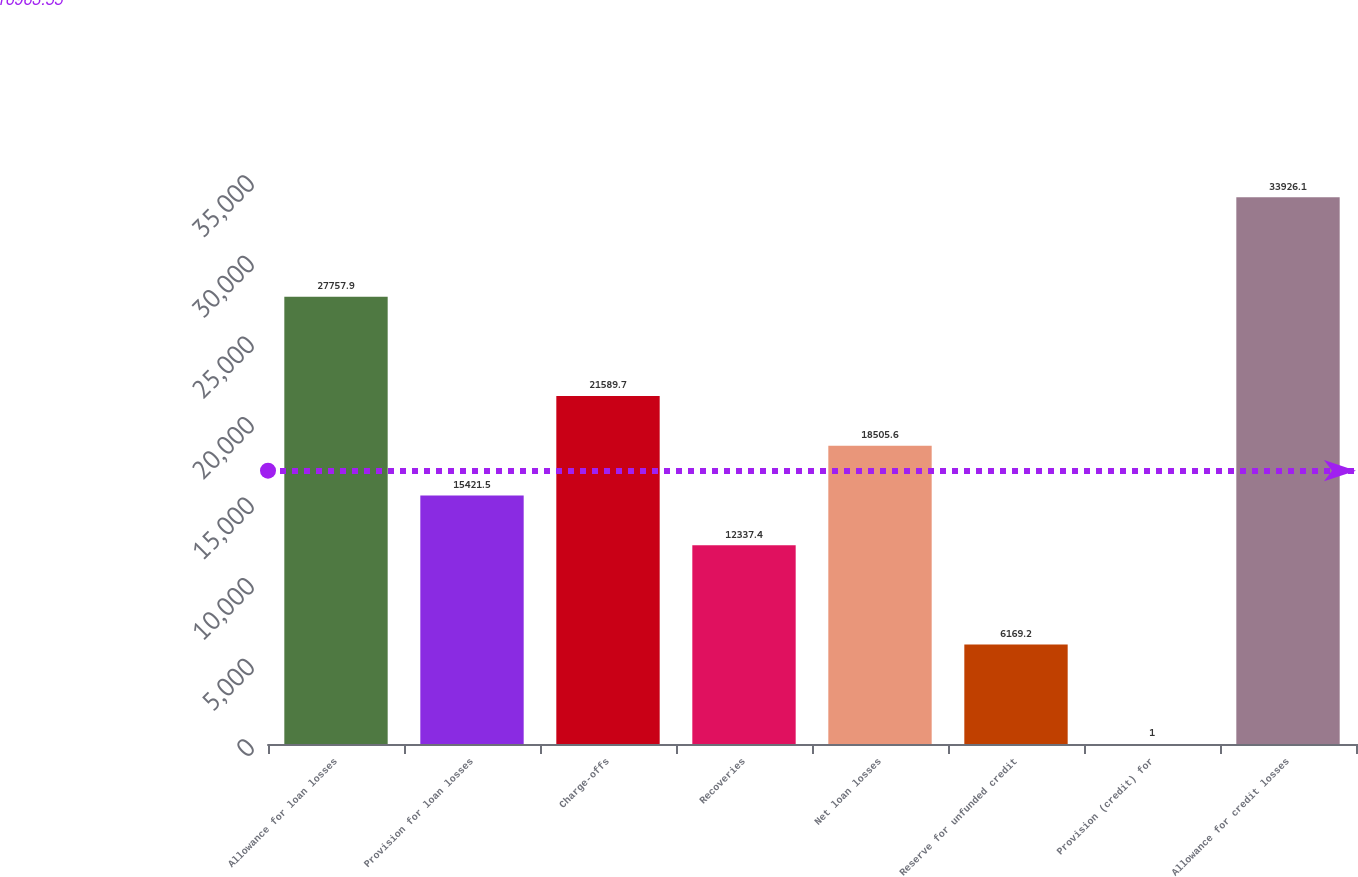Convert chart. <chart><loc_0><loc_0><loc_500><loc_500><bar_chart><fcel>Allowance for loan losses<fcel>Provision for loan losses<fcel>Charge-offs<fcel>Recoveries<fcel>Net loan losses<fcel>Reserve for unfunded credit<fcel>Provision (credit) for<fcel>Allowance for credit losses<nl><fcel>27757.9<fcel>15421.5<fcel>21589.7<fcel>12337.4<fcel>18505.6<fcel>6169.2<fcel>1<fcel>33926.1<nl></chart> 